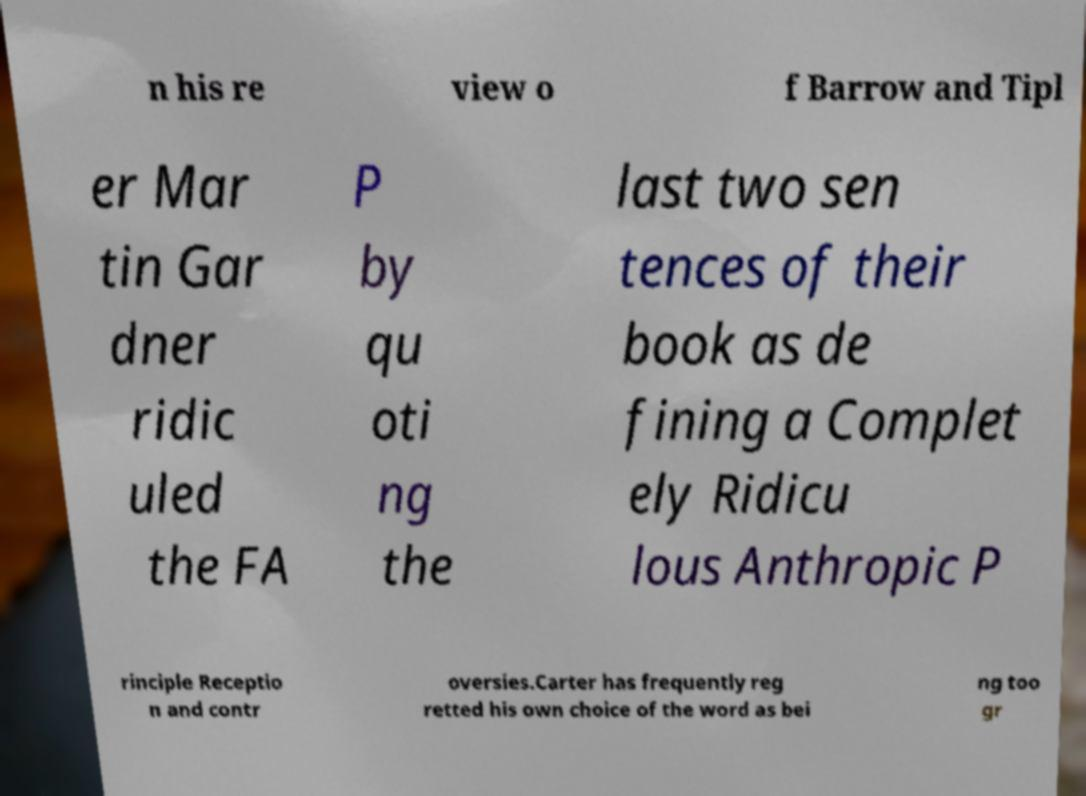Can you read and provide the text displayed in the image?This photo seems to have some interesting text. Can you extract and type it out for me? n his re view o f Barrow and Tipl er Mar tin Gar dner ridic uled the FA P by qu oti ng the last two sen tences of their book as de fining a Complet ely Ridicu lous Anthropic P rinciple Receptio n and contr oversies.Carter has frequently reg retted his own choice of the word as bei ng too gr 